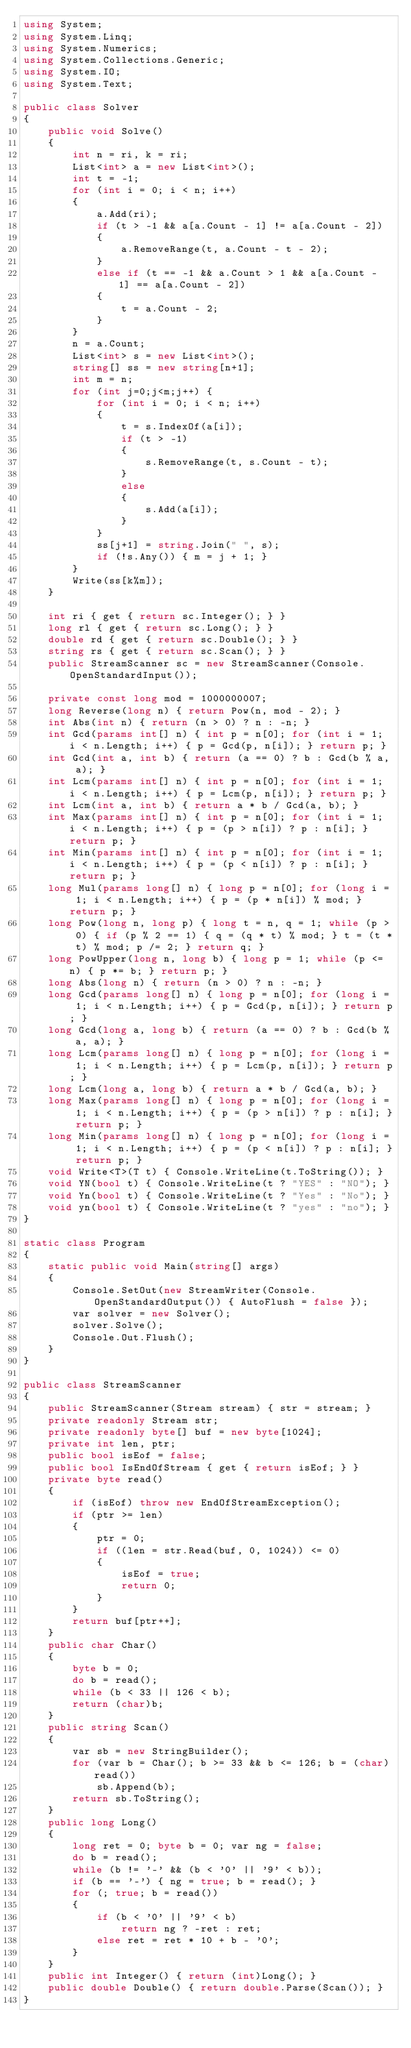<code> <loc_0><loc_0><loc_500><loc_500><_C#_>using System;
using System.Linq;
using System.Numerics;
using System.Collections.Generic;
using System.IO;
using System.Text;

public class Solver
{
    public void Solve()
    {
        int n = ri, k = ri;
        List<int> a = new List<int>();
        int t = -1;
        for (int i = 0; i < n; i++)
        {
            a.Add(ri);
            if (t > -1 && a[a.Count - 1] != a[a.Count - 2])
            {
                a.RemoveRange(t, a.Count - t - 2);
            }
            else if (t == -1 && a.Count > 1 && a[a.Count - 1] == a[a.Count - 2])
            {
                t = a.Count - 2;
            }
        }
        n = a.Count;
        List<int> s = new List<int>();
        string[] ss = new string[n+1];
        int m = n;
        for (int j=0;j<m;j++) {
            for (int i = 0; i < n; i++)
            {
                t = s.IndexOf(a[i]);
                if (t > -1)
                {
                    s.RemoveRange(t, s.Count - t);
                }
                else
                {
                    s.Add(a[i]);
                }
            }
            ss[j+1] = string.Join(" ", s);
            if (!s.Any()) { m = j + 1; }
        }
        Write(ss[k%m]);
    }

    int ri { get { return sc.Integer(); } }
    long rl { get { return sc.Long(); } }
    double rd { get { return sc.Double(); } }
    string rs { get { return sc.Scan(); } }
    public StreamScanner sc = new StreamScanner(Console.OpenStandardInput());
    
    private const long mod = 1000000007;
    long Reverse(long n) { return Pow(n, mod - 2); }
    int Abs(int n) { return (n > 0) ? n : -n; }
    int Gcd(params int[] n) { int p = n[0]; for (int i = 1; i < n.Length; i++) { p = Gcd(p, n[i]); } return p; }
    int Gcd(int a, int b) { return (a == 0) ? b : Gcd(b % a, a); }
    int Lcm(params int[] n) { int p = n[0]; for (int i = 1; i < n.Length; i++) { p = Lcm(p, n[i]); } return p; }
    int Lcm(int a, int b) { return a * b / Gcd(a, b); }
    int Max(params int[] n) { int p = n[0]; for (int i = 1; i < n.Length; i++) { p = (p > n[i]) ? p : n[i]; } return p; }
    int Min(params int[] n) { int p = n[0]; for (int i = 1; i < n.Length; i++) { p = (p < n[i]) ? p : n[i]; } return p; }
    long Mul(params long[] n) { long p = n[0]; for (long i = 1; i < n.Length; i++) { p = (p * n[i]) % mod; } return p; }
    long Pow(long n, long p) { long t = n, q = 1; while (p > 0) { if (p % 2 == 1) { q = (q * t) % mod; } t = (t * t) % mod; p /= 2; } return q; }
    long PowUpper(long n, long b) { long p = 1; while (p <= n) { p *= b; } return p; }
    long Abs(long n) { return (n > 0) ? n : -n; }
    long Gcd(params long[] n) { long p = n[0]; for (long i = 1; i < n.Length; i++) { p = Gcd(p, n[i]); } return p; }
    long Gcd(long a, long b) { return (a == 0) ? b : Gcd(b % a, a); }
    long Lcm(params long[] n) { long p = n[0]; for (long i = 1; i < n.Length; i++) { p = Lcm(p, n[i]); } return p; }
    long Lcm(long a, long b) { return a * b / Gcd(a, b); }
    long Max(params long[] n) { long p = n[0]; for (long i = 1; i < n.Length; i++) { p = (p > n[i]) ? p : n[i]; } return p; }
    long Min(params long[] n) { long p = n[0]; for (long i = 1; i < n.Length; i++) { p = (p < n[i]) ? p : n[i]; } return p; }
    void Write<T>(T t) { Console.WriteLine(t.ToString()); }
    void YN(bool t) { Console.WriteLine(t ? "YES" : "NO"); }
    void Yn(bool t) { Console.WriteLine(t ? "Yes" : "No"); }
    void yn(bool t) { Console.WriteLine(t ? "yes" : "no"); }
}

static class Program
{
    static public void Main(string[] args)
    {
        Console.SetOut(new StreamWriter(Console.OpenStandardOutput()) { AutoFlush = false });
        var solver = new Solver();
        solver.Solve();
        Console.Out.Flush();
    }
}

public class StreamScanner
{
    public StreamScanner(Stream stream) { str = stream; }
    private readonly Stream str;
    private readonly byte[] buf = new byte[1024];
    private int len, ptr;
    public bool isEof = false;
    public bool IsEndOfStream { get { return isEof; } }
    private byte read()
    {
        if (isEof) throw new EndOfStreamException();
        if (ptr >= len)
        {
            ptr = 0;
            if ((len = str.Read(buf, 0, 1024)) <= 0)
            {
                isEof = true;
                return 0;
            }
        }
        return buf[ptr++];
    }
    public char Char()
    {
        byte b = 0;
        do b = read();
        while (b < 33 || 126 < b);
        return (char)b;
    }
    public string Scan()
    {
        var sb = new StringBuilder();
        for (var b = Char(); b >= 33 && b <= 126; b = (char)read())
            sb.Append(b);
        return sb.ToString();
    }
    public long Long()
    {
        long ret = 0; byte b = 0; var ng = false;
        do b = read();
        while (b != '-' && (b < '0' || '9' < b));
        if (b == '-') { ng = true; b = read(); }
        for (; true; b = read())
        {
            if (b < '0' || '9' < b)
                return ng ? -ret : ret;
            else ret = ret * 10 + b - '0';
        }
    }
    public int Integer() { return (int)Long(); }
    public double Double() { return double.Parse(Scan()); }
}
</code> 